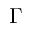Convert formula to latex. <formula><loc_0><loc_0><loc_500><loc_500>\Gamma</formula> 